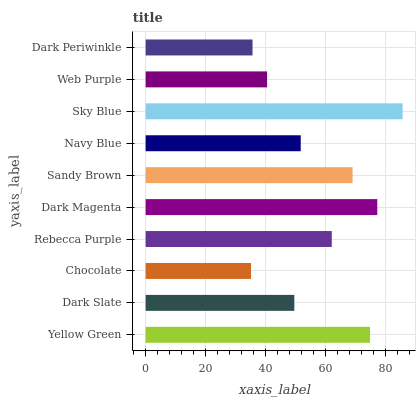Is Chocolate the minimum?
Answer yes or no. Yes. Is Sky Blue the maximum?
Answer yes or no. Yes. Is Dark Slate the minimum?
Answer yes or no. No. Is Dark Slate the maximum?
Answer yes or no. No. Is Yellow Green greater than Dark Slate?
Answer yes or no. Yes. Is Dark Slate less than Yellow Green?
Answer yes or no. Yes. Is Dark Slate greater than Yellow Green?
Answer yes or no. No. Is Yellow Green less than Dark Slate?
Answer yes or no. No. Is Rebecca Purple the high median?
Answer yes or no. Yes. Is Navy Blue the low median?
Answer yes or no. Yes. Is Sandy Brown the high median?
Answer yes or no. No. Is Dark Magenta the low median?
Answer yes or no. No. 